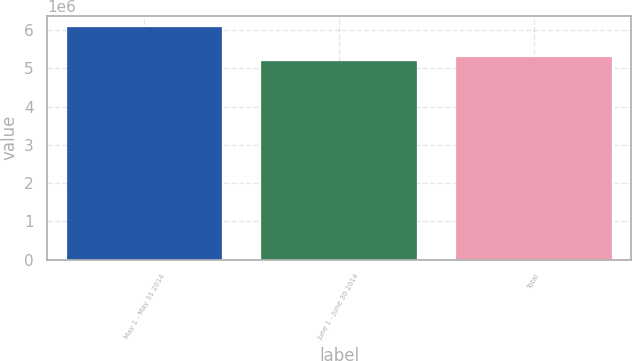Convert chart. <chart><loc_0><loc_0><loc_500><loc_500><bar_chart><fcel>May 1 - May 31 2014<fcel>June 1 - June 30 2014<fcel>Total<nl><fcel>6.06402e+06<fcel>5.19606e+06<fcel>5.28285e+06<nl></chart> 